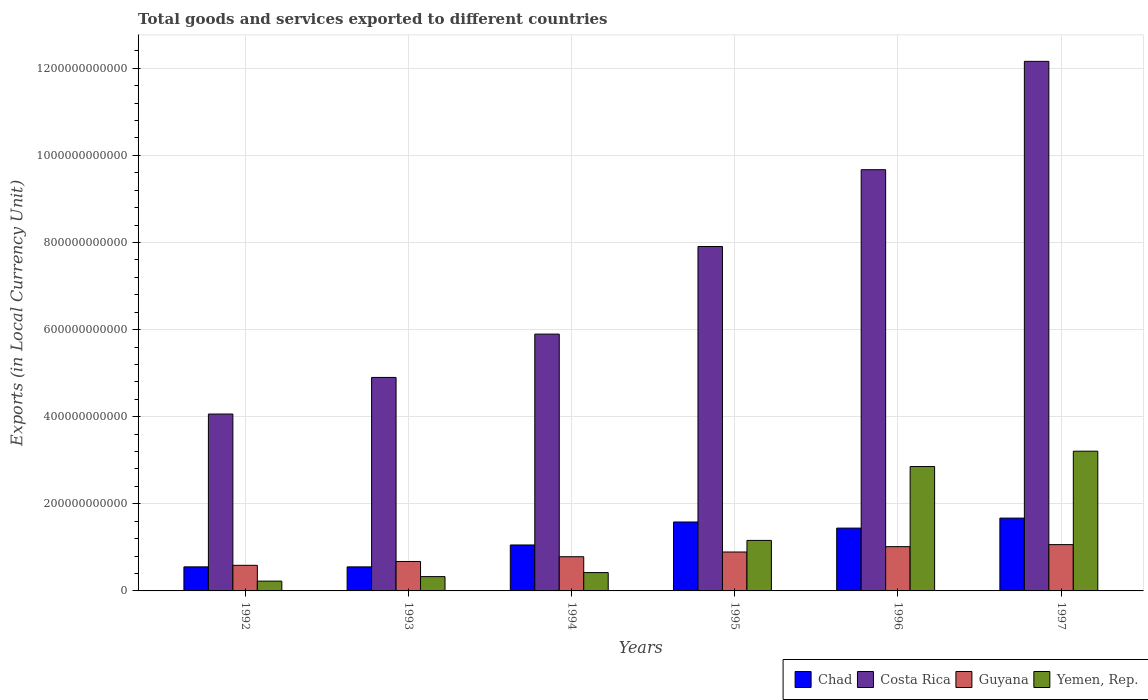How many different coloured bars are there?
Provide a short and direct response. 4. Are the number of bars on each tick of the X-axis equal?
Your answer should be compact. Yes. What is the label of the 3rd group of bars from the left?
Your answer should be compact. 1994. In how many cases, is the number of bars for a given year not equal to the number of legend labels?
Ensure brevity in your answer.  0. What is the Amount of goods and services exports in Yemen, Rep. in 1997?
Ensure brevity in your answer.  3.21e+11. Across all years, what is the maximum Amount of goods and services exports in Chad?
Make the answer very short. 1.67e+11. Across all years, what is the minimum Amount of goods and services exports in Costa Rica?
Your answer should be compact. 4.06e+11. What is the total Amount of goods and services exports in Chad in the graph?
Ensure brevity in your answer.  6.86e+11. What is the difference between the Amount of goods and services exports in Guyana in 1992 and that in 1994?
Provide a short and direct response. -1.97e+1. What is the difference between the Amount of goods and services exports in Guyana in 1992 and the Amount of goods and services exports in Chad in 1997?
Provide a short and direct response. -1.08e+11. What is the average Amount of goods and services exports in Yemen, Rep. per year?
Your response must be concise. 1.37e+11. In the year 1992, what is the difference between the Amount of goods and services exports in Yemen, Rep. and Amount of goods and services exports in Costa Rica?
Provide a succinct answer. -3.84e+11. In how many years, is the Amount of goods and services exports in Chad greater than 280000000000 LCU?
Your response must be concise. 0. What is the ratio of the Amount of goods and services exports in Chad in 1993 to that in 1997?
Your answer should be very brief. 0.33. Is the difference between the Amount of goods and services exports in Yemen, Rep. in 1992 and 1993 greater than the difference between the Amount of goods and services exports in Costa Rica in 1992 and 1993?
Offer a very short reply. Yes. What is the difference between the highest and the second highest Amount of goods and services exports in Chad?
Your answer should be compact. 8.92e+09. What is the difference between the highest and the lowest Amount of goods and services exports in Chad?
Offer a very short reply. 1.12e+11. In how many years, is the Amount of goods and services exports in Costa Rica greater than the average Amount of goods and services exports in Costa Rica taken over all years?
Provide a succinct answer. 3. What does the 2nd bar from the left in 1994 represents?
Your answer should be compact. Costa Rica. What does the 2nd bar from the right in 1992 represents?
Your response must be concise. Guyana. How many bars are there?
Offer a terse response. 24. Are all the bars in the graph horizontal?
Keep it short and to the point. No. What is the difference between two consecutive major ticks on the Y-axis?
Your answer should be very brief. 2.00e+11. Are the values on the major ticks of Y-axis written in scientific E-notation?
Provide a succinct answer. No. Does the graph contain any zero values?
Keep it short and to the point. No. Does the graph contain grids?
Ensure brevity in your answer.  Yes. How many legend labels are there?
Keep it short and to the point. 4. How are the legend labels stacked?
Offer a terse response. Horizontal. What is the title of the graph?
Offer a very short reply. Total goods and services exported to different countries. Does "Kazakhstan" appear as one of the legend labels in the graph?
Give a very brief answer. No. What is the label or title of the X-axis?
Make the answer very short. Years. What is the label or title of the Y-axis?
Your answer should be compact. Exports (in Local Currency Unit). What is the Exports (in Local Currency Unit) of Chad in 1992?
Your answer should be compact. 5.52e+1. What is the Exports (in Local Currency Unit) of Costa Rica in 1992?
Your response must be concise. 4.06e+11. What is the Exports (in Local Currency Unit) of Guyana in 1992?
Your response must be concise. 5.88e+1. What is the Exports (in Local Currency Unit) of Yemen, Rep. in 1992?
Your answer should be compact. 2.25e+1. What is the Exports (in Local Currency Unit) in Chad in 1993?
Make the answer very short. 5.52e+1. What is the Exports (in Local Currency Unit) of Costa Rica in 1993?
Your answer should be compact. 4.90e+11. What is the Exports (in Local Currency Unit) of Guyana in 1993?
Give a very brief answer. 6.76e+1. What is the Exports (in Local Currency Unit) of Yemen, Rep. in 1993?
Provide a short and direct response. 3.28e+1. What is the Exports (in Local Currency Unit) of Chad in 1994?
Make the answer very short. 1.06e+11. What is the Exports (in Local Currency Unit) of Costa Rica in 1994?
Make the answer very short. 5.90e+11. What is the Exports (in Local Currency Unit) in Guyana in 1994?
Your answer should be very brief. 7.85e+1. What is the Exports (in Local Currency Unit) of Yemen, Rep. in 1994?
Provide a succinct answer. 4.21e+1. What is the Exports (in Local Currency Unit) of Chad in 1995?
Provide a short and direct response. 1.58e+11. What is the Exports (in Local Currency Unit) in Costa Rica in 1995?
Your answer should be very brief. 7.91e+11. What is the Exports (in Local Currency Unit) in Guyana in 1995?
Keep it short and to the point. 8.93e+1. What is the Exports (in Local Currency Unit) of Yemen, Rep. in 1995?
Give a very brief answer. 1.16e+11. What is the Exports (in Local Currency Unit) in Chad in 1996?
Offer a terse response. 1.44e+11. What is the Exports (in Local Currency Unit) of Costa Rica in 1996?
Provide a short and direct response. 9.67e+11. What is the Exports (in Local Currency Unit) of Guyana in 1996?
Make the answer very short. 1.02e+11. What is the Exports (in Local Currency Unit) in Yemen, Rep. in 1996?
Make the answer very short. 2.86e+11. What is the Exports (in Local Currency Unit) of Chad in 1997?
Offer a very short reply. 1.67e+11. What is the Exports (in Local Currency Unit) of Costa Rica in 1997?
Give a very brief answer. 1.22e+12. What is the Exports (in Local Currency Unit) of Guyana in 1997?
Make the answer very short. 1.06e+11. What is the Exports (in Local Currency Unit) in Yemen, Rep. in 1997?
Provide a short and direct response. 3.21e+11. Across all years, what is the maximum Exports (in Local Currency Unit) in Chad?
Your response must be concise. 1.67e+11. Across all years, what is the maximum Exports (in Local Currency Unit) of Costa Rica?
Your answer should be very brief. 1.22e+12. Across all years, what is the maximum Exports (in Local Currency Unit) of Guyana?
Keep it short and to the point. 1.06e+11. Across all years, what is the maximum Exports (in Local Currency Unit) in Yemen, Rep.?
Your answer should be compact. 3.21e+11. Across all years, what is the minimum Exports (in Local Currency Unit) of Chad?
Provide a short and direct response. 5.52e+1. Across all years, what is the minimum Exports (in Local Currency Unit) in Costa Rica?
Provide a short and direct response. 4.06e+11. Across all years, what is the minimum Exports (in Local Currency Unit) of Guyana?
Ensure brevity in your answer.  5.88e+1. Across all years, what is the minimum Exports (in Local Currency Unit) of Yemen, Rep.?
Give a very brief answer. 2.25e+1. What is the total Exports (in Local Currency Unit) in Chad in the graph?
Give a very brief answer. 6.86e+11. What is the total Exports (in Local Currency Unit) of Costa Rica in the graph?
Provide a short and direct response. 4.46e+12. What is the total Exports (in Local Currency Unit) in Guyana in the graph?
Provide a short and direct response. 5.02e+11. What is the total Exports (in Local Currency Unit) of Yemen, Rep. in the graph?
Your answer should be very brief. 8.20e+11. What is the difference between the Exports (in Local Currency Unit) in Chad in 1992 and that in 1993?
Your answer should be very brief. 4.00e+07. What is the difference between the Exports (in Local Currency Unit) of Costa Rica in 1992 and that in 1993?
Provide a succinct answer. -8.41e+1. What is the difference between the Exports (in Local Currency Unit) in Guyana in 1992 and that in 1993?
Make the answer very short. -8.82e+09. What is the difference between the Exports (in Local Currency Unit) of Yemen, Rep. in 1992 and that in 1993?
Your answer should be compact. -1.03e+1. What is the difference between the Exports (in Local Currency Unit) in Chad in 1992 and that in 1994?
Ensure brevity in your answer.  -5.03e+1. What is the difference between the Exports (in Local Currency Unit) of Costa Rica in 1992 and that in 1994?
Ensure brevity in your answer.  -1.84e+11. What is the difference between the Exports (in Local Currency Unit) in Guyana in 1992 and that in 1994?
Give a very brief answer. -1.97e+1. What is the difference between the Exports (in Local Currency Unit) of Yemen, Rep. in 1992 and that in 1994?
Your answer should be compact. -1.96e+1. What is the difference between the Exports (in Local Currency Unit) of Chad in 1992 and that in 1995?
Your answer should be very brief. -1.03e+11. What is the difference between the Exports (in Local Currency Unit) in Costa Rica in 1992 and that in 1995?
Make the answer very short. -3.85e+11. What is the difference between the Exports (in Local Currency Unit) in Guyana in 1992 and that in 1995?
Make the answer very short. -3.06e+1. What is the difference between the Exports (in Local Currency Unit) in Yemen, Rep. in 1992 and that in 1995?
Your response must be concise. -9.34e+1. What is the difference between the Exports (in Local Currency Unit) in Chad in 1992 and that in 1996?
Ensure brevity in your answer.  -8.90e+1. What is the difference between the Exports (in Local Currency Unit) of Costa Rica in 1992 and that in 1996?
Your response must be concise. -5.61e+11. What is the difference between the Exports (in Local Currency Unit) in Guyana in 1992 and that in 1996?
Offer a very short reply. -4.29e+1. What is the difference between the Exports (in Local Currency Unit) of Yemen, Rep. in 1992 and that in 1996?
Provide a succinct answer. -2.63e+11. What is the difference between the Exports (in Local Currency Unit) of Chad in 1992 and that in 1997?
Your answer should be very brief. -1.12e+11. What is the difference between the Exports (in Local Currency Unit) of Costa Rica in 1992 and that in 1997?
Ensure brevity in your answer.  -8.10e+11. What is the difference between the Exports (in Local Currency Unit) of Guyana in 1992 and that in 1997?
Your answer should be compact. -4.75e+1. What is the difference between the Exports (in Local Currency Unit) in Yemen, Rep. in 1992 and that in 1997?
Offer a terse response. -2.98e+11. What is the difference between the Exports (in Local Currency Unit) in Chad in 1993 and that in 1994?
Your answer should be compact. -5.03e+1. What is the difference between the Exports (in Local Currency Unit) of Costa Rica in 1993 and that in 1994?
Offer a terse response. -9.95e+1. What is the difference between the Exports (in Local Currency Unit) in Guyana in 1993 and that in 1994?
Give a very brief answer. -1.09e+1. What is the difference between the Exports (in Local Currency Unit) in Yemen, Rep. in 1993 and that in 1994?
Give a very brief answer. -9.26e+09. What is the difference between the Exports (in Local Currency Unit) in Chad in 1993 and that in 1995?
Offer a terse response. -1.03e+11. What is the difference between the Exports (in Local Currency Unit) in Costa Rica in 1993 and that in 1995?
Offer a very short reply. -3.01e+11. What is the difference between the Exports (in Local Currency Unit) in Guyana in 1993 and that in 1995?
Your answer should be compact. -2.17e+1. What is the difference between the Exports (in Local Currency Unit) of Yemen, Rep. in 1993 and that in 1995?
Ensure brevity in your answer.  -8.31e+1. What is the difference between the Exports (in Local Currency Unit) in Chad in 1993 and that in 1996?
Offer a very short reply. -8.90e+1. What is the difference between the Exports (in Local Currency Unit) in Costa Rica in 1993 and that in 1996?
Your response must be concise. -4.77e+11. What is the difference between the Exports (in Local Currency Unit) in Guyana in 1993 and that in 1996?
Your response must be concise. -3.40e+1. What is the difference between the Exports (in Local Currency Unit) in Yemen, Rep. in 1993 and that in 1996?
Give a very brief answer. -2.53e+11. What is the difference between the Exports (in Local Currency Unit) of Chad in 1993 and that in 1997?
Offer a very short reply. -1.12e+11. What is the difference between the Exports (in Local Currency Unit) in Costa Rica in 1993 and that in 1997?
Ensure brevity in your answer.  -7.26e+11. What is the difference between the Exports (in Local Currency Unit) of Guyana in 1993 and that in 1997?
Ensure brevity in your answer.  -3.87e+1. What is the difference between the Exports (in Local Currency Unit) in Yemen, Rep. in 1993 and that in 1997?
Your answer should be compact. -2.88e+11. What is the difference between the Exports (in Local Currency Unit) of Chad in 1994 and that in 1995?
Keep it short and to the point. -5.28e+1. What is the difference between the Exports (in Local Currency Unit) in Costa Rica in 1994 and that in 1995?
Your answer should be very brief. -2.01e+11. What is the difference between the Exports (in Local Currency Unit) of Guyana in 1994 and that in 1995?
Offer a terse response. -1.08e+1. What is the difference between the Exports (in Local Currency Unit) in Yemen, Rep. in 1994 and that in 1995?
Provide a short and direct response. -7.39e+1. What is the difference between the Exports (in Local Currency Unit) of Chad in 1994 and that in 1996?
Your answer should be compact. -3.88e+1. What is the difference between the Exports (in Local Currency Unit) of Costa Rica in 1994 and that in 1996?
Offer a very short reply. -3.77e+11. What is the difference between the Exports (in Local Currency Unit) in Guyana in 1994 and that in 1996?
Provide a short and direct response. -2.31e+1. What is the difference between the Exports (in Local Currency Unit) in Yemen, Rep. in 1994 and that in 1996?
Make the answer very short. -2.43e+11. What is the difference between the Exports (in Local Currency Unit) in Chad in 1994 and that in 1997?
Give a very brief answer. -6.17e+1. What is the difference between the Exports (in Local Currency Unit) in Costa Rica in 1994 and that in 1997?
Offer a very short reply. -6.26e+11. What is the difference between the Exports (in Local Currency Unit) of Guyana in 1994 and that in 1997?
Make the answer very short. -2.78e+1. What is the difference between the Exports (in Local Currency Unit) of Yemen, Rep. in 1994 and that in 1997?
Provide a short and direct response. -2.79e+11. What is the difference between the Exports (in Local Currency Unit) in Chad in 1995 and that in 1996?
Your answer should be very brief. 1.40e+1. What is the difference between the Exports (in Local Currency Unit) in Costa Rica in 1995 and that in 1996?
Your response must be concise. -1.76e+11. What is the difference between the Exports (in Local Currency Unit) of Guyana in 1995 and that in 1996?
Provide a short and direct response. -1.23e+1. What is the difference between the Exports (in Local Currency Unit) of Yemen, Rep. in 1995 and that in 1996?
Ensure brevity in your answer.  -1.70e+11. What is the difference between the Exports (in Local Currency Unit) in Chad in 1995 and that in 1997?
Ensure brevity in your answer.  -8.92e+09. What is the difference between the Exports (in Local Currency Unit) in Costa Rica in 1995 and that in 1997?
Provide a succinct answer. -4.25e+11. What is the difference between the Exports (in Local Currency Unit) of Guyana in 1995 and that in 1997?
Give a very brief answer. -1.70e+1. What is the difference between the Exports (in Local Currency Unit) of Yemen, Rep. in 1995 and that in 1997?
Offer a very short reply. -2.05e+11. What is the difference between the Exports (in Local Currency Unit) in Chad in 1996 and that in 1997?
Offer a terse response. -2.29e+1. What is the difference between the Exports (in Local Currency Unit) in Costa Rica in 1996 and that in 1997?
Your answer should be very brief. -2.49e+11. What is the difference between the Exports (in Local Currency Unit) in Guyana in 1996 and that in 1997?
Your answer should be very brief. -4.68e+09. What is the difference between the Exports (in Local Currency Unit) of Yemen, Rep. in 1996 and that in 1997?
Offer a terse response. -3.52e+1. What is the difference between the Exports (in Local Currency Unit) of Chad in 1992 and the Exports (in Local Currency Unit) of Costa Rica in 1993?
Give a very brief answer. -4.35e+11. What is the difference between the Exports (in Local Currency Unit) of Chad in 1992 and the Exports (in Local Currency Unit) of Guyana in 1993?
Your answer should be very brief. -1.23e+1. What is the difference between the Exports (in Local Currency Unit) in Chad in 1992 and the Exports (in Local Currency Unit) in Yemen, Rep. in 1993?
Your answer should be very brief. 2.24e+1. What is the difference between the Exports (in Local Currency Unit) in Costa Rica in 1992 and the Exports (in Local Currency Unit) in Guyana in 1993?
Keep it short and to the point. 3.39e+11. What is the difference between the Exports (in Local Currency Unit) in Costa Rica in 1992 and the Exports (in Local Currency Unit) in Yemen, Rep. in 1993?
Your response must be concise. 3.73e+11. What is the difference between the Exports (in Local Currency Unit) of Guyana in 1992 and the Exports (in Local Currency Unit) of Yemen, Rep. in 1993?
Provide a short and direct response. 2.59e+1. What is the difference between the Exports (in Local Currency Unit) of Chad in 1992 and the Exports (in Local Currency Unit) of Costa Rica in 1994?
Keep it short and to the point. -5.34e+11. What is the difference between the Exports (in Local Currency Unit) of Chad in 1992 and the Exports (in Local Currency Unit) of Guyana in 1994?
Provide a short and direct response. -2.33e+1. What is the difference between the Exports (in Local Currency Unit) in Chad in 1992 and the Exports (in Local Currency Unit) in Yemen, Rep. in 1994?
Make the answer very short. 1.32e+1. What is the difference between the Exports (in Local Currency Unit) in Costa Rica in 1992 and the Exports (in Local Currency Unit) in Guyana in 1994?
Offer a very short reply. 3.28e+11. What is the difference between the Exports (in Local Currency Unit) of Costa Rica in 1992 and the Exports (in Local Currency Unit) of Yemen, Rep. in 1994?
Offer a very short reply. 3.64e+11. What is the difference between the Exports (in Local Currency Unit) of Guyana in 1992 and the Exports (in Local Currency Unit) of Yemen, Rep. in 1994?
Your answer should be very brief. 1.67e+1. What is the difference between the Exports (in Local Currency Unit) of Chad in 1992 and the Exports (in Local Currency Unit) of Costa Rica in 1995?
Provide a short and direct response. -7.36e+11. What is the difference between the Exports (in Local Currency Unit) of Chad in 1992 and the Exports (in Local Currency Unit) of Guyana in 1995?
Your response must be concise. -3.41e+1. What is the difference between the Exports (in Local Currency Unit) of Chad in 1992 and the Exports (in Local Currency Unit) of Yemen, Rep. in 1995?
Your answer should be compact. -6.07e+1. What is the difference between the Exports (in Local Currency Unit) of Costa Rica in 1992 and the Exports (in Local Currency Unit) of Guyana in 1995?
Offer a very short reply. 3.17e+11. What is the difference between the Exports (in Local Currency Unit) in Costa Rica in 1992 and the Exports (in Local Currency Unit) in Yemen, Rep. in 1995?
Provide a succinct answer. 2.90e+11. What is the difference between the Exports (in Local Currency Unit) of Guyana in 1992 and the Exports (in Local Currency Unit) of Yemen, Rep. in 1995?
Your answer should be very brief. -5.72e+1. What is the difference between the Exports (in Local Currency Unit) of Chad in 1992 and the Exports (in Local Currency Unit) of Costa Rica in 1996?
Your response must be concise. -9.12e+11. What is the difference between the Exports (in Local Currency Unit) of Chad in 1992 and the Exports (in Local Currency Unit) of Guyana in 1996?
Give a very brief answer. -4.64e+1. What is the difference between the Exports (in Local Currency Unit) in Chad in 1992 and the Exports (in Local Currency Unit) in Yemen, Rep. in 1996?
Your answer should be very brief. -2.30e+11. What is the difference between the Exports (in Local Currency Unit) of Costa Rica in 1992 and the Exports (in Local Currency Unit) of Guyana in 1996?
Your answer should be compact. 3.04e+11. What is the difference between the Exports (in Local Currency Unit) of Costa Rica in 1992 and the Exports (in Local Currency Unit) of Yemen, Rep. in 1996?
Offer a very short reply. 1.21e+11. What is the difference between the Exports (in Local Currency Unit) in Guyana in 1992 and the Exports (in Local Currency Unit) in Yemen, Rep. in 1996?
Give a very brief answer. -2.27e+11. What is the difference between the Exports (in Local Currency Unit) of Chad in 1992 and the Exports (in Local Currency Unit) of Costa Rica in 1997?
Your answer should be very brief. -1.16e+12. What is the difference between the Exports (in Local Currency Unit) in Chad in 1992 and the Exports (in Local Currency Unit) in Guyana in 1997?
Your answer should be very brief. -5.11e+1. What is the difference between the Exports (in Local Currency Unit) of Chad in 1992 and the Exports (in Local Currency Unit) of Yemen, Rep. in 1997?
Offer a terse response. -2.66e+11. What is the difference between the Exports (in Local Currency Unit) in Costa Rica in 1992 and the Exports (in Local Currency Unit) in Guyana in 1997?
Keep it short and to the point. 3.00e+11. What is the difference between the Exports (in Local Currency Unit) of Costa Rica in 1992 and the Exports (in Local Currency Unit) of Yemen, Rep. in 1997?
Ensure brevity in your answer.  8.53e+1. What is the difference between the Exports (in Local Currency Unit) in Guyana in 1992 and the Exports (in Local Currency Unit) in Yemen, Rep. in 1997?
Offer a very short reply. -2.62e+11. What is the difference between the Exports (in Local Currency Unit) in Chad in 1993 and the Exports (in Local Currency Unit) in Costa Rica in 1994?
Your answer should be compact. -5.34e+11. What is the difference between the Exports (in Local Currency Unit) of Chad in 1993 and the Exports (in Local Currency Unit) of Guyana in 1994?
Give a very brief answer. -2.33e+1. What is the difference between the Exports (in Local Currency Unit) in Chad in 1993 and the Exports (in Local Currency Unit) in Yemen, Rep. in 1994?
Offer a terse response. 1.31e+1. What is the difference between the Exports (in Local Currency Unit) of Costa Rica in 1993 and the Exports (in Local Currency Unit) of Guyana in 1994?
Provide a short and direct response. 4.12e+11. What is the difference between the Exports (in Local Currency Unit) of Costa Rica in 1993 and the Exports (in Local Currency Unit) of Yemen, Rep. in 1994?
Your answer should be compact. 4.48e+11. What is the difference between the Exports (in Local Currency Unit) of Guyana in 1993 and the Exports (in Local Currency Unit) of Yemen, Rep. in 1994?
Keep it short and to the point. 2.55e+1. What is the difference between the Exports (in Local Currency Unit) of Chad in 1993 and the Exports (in Local Currency Unit) of Costa Rica in 1995?
Your answer should be very brief. -7.36e+11. What is the difference between the Exports (in Local Currency Unit) of Chad in 1993 and the Exports (in Local Currency Unit) of Guyana in 1995?
Your answer should be very brief. -3.41e+1. What is the difference between the Exports (in Local Currency Unit) of Chad in 1993 and the Exports (in Local Currency Unit) of Yemen, Rep. in 1995?
Offer a very short reply. -6.08e+1. What is the difference between the Exports (in Local Currency Unit) of Costa Rica in 1993 and the Exports (in Local Currency Unit) of Guyana in 1995?
Ensure brevity in your answer.  4.01e+11. What is the difference between the Exports (in Local Currency Unit) in Costa Rica in 1993 and the Exports (in Local Currency Unit) in Yemen, Rep. in 1995?
Make the answer very short. 3.74e+11. What is the difference between the Exports (in Local Currency Unit) of Guyana in 1993 and the Exports (in Local Currency Unit) of Yemen, Rep. in 1995?
Provide a succinct answer. -4.84e+1. What is the difference between the Exports (in Local Currency Unit) in Chad in 1993 and the Exports (in Local Currency Unit) in Costa Rica in 1996?
Give a very brief answer. -9.12e+11. What is the difference between the Exports (in Local Currency Unit) of Chad in 1993 and the Exports (in Local Currency Unit) of Guyana in 1996?
Offer a very short reply. -4.64e+1. What is the difference between the Exports (in Local Currency Unit) in Chad in 1993 and the Exports (in Local Currency Unit) in Yemen, Rep. in 1996?
Make the answer very short. -2.30e+11. What is the difference between the Exports (in Local Currency Unit) of Costa Rica in 1993 and the Exports (in Local Currency Unit) of Guyana in 1996?
Keep it short and to the point. 3.89e+11. What is the difference between the Exports (in Local Currency Unit) in Costa Rica in 1993 and the Exports (in Local Currency Unit) in Yemen, Rep. in 1996?
Offer a terse response. 2.05e+11. What is the difference between the Exports (in Local Currency Unit) of Guyana in 1993 and the Exports (in Local Currency Unit) of Yemen, Rep. in 1996?
Offer a very short reply. -2.18e+11. What is the difference between the Exports (in Local Currency Unit) in Chad in 1993 and the Exports (in Local Currency Unit) in Costa Rica in 1997?
Your answer should be compact. -1.16e+12. What is the difference between the Exports (in Local Currency Unit) in Chad in 1993 and the Exports (in Local Currency Unit) in Guyana in 1997?
Ensure brevity in your answer.  -5.11e+1. What is the difference between the Exports (in Local Currency Unit) in Chad in 1993 and the Exports (in Local Currency Unit) in Yemen, Rep. in 1997?
Keep it short and to the point. -2.66e+11. What is the difference between the Exports (in Local Currency Unit) of Costa Rica in 1993 and the Exports (in Local Currency Unit) of Guyana in 1997?
Your response must be concise. 3.84e+11. What is the difference between the Exports (in Local Currency Unit) in Costa Rica in 1993 and the Exports (in Local Currency Unit) in Yemen, Rep. in 1997?
Give a very brief answer. 1.69e+11. What is the difference between the Exports (in Local Currency Unit) in Guyana in 1993 and the Exports (in Local Currency Unit) in Yemen, Rep. in 1997?
Keep it short and to the point. -2.53e+11. What is the difference between the Exports (in Local Currency Unit) of Chad in 1994 and the Exports (in Local Currency Unit) of Costa Rica in 1995?
Your answer should be compact. -6.85e+11. What is the difference between the Exports (in Local Currency Unit) of Chad in 1994 and the Exports (in Local Currency Unit) of Guyana in 1995?
Ensure brevity in your answer.  1.62e+1. What is the difference between the Exports (in Local Currency Unit) of Chad in 1994 and the Exports (in Local Currency Unit) of Yemen, Rep. in 1995?
Offer a very short reply. -1.05e+1. What is the difference between the Exports (in Local Currency Unit) in Costa Rica in 1994 and the Exports (in Local Currency Unit) in Guyana in 1995?
Offer a very short reply. 5.00e+11. What is the difference between the Exports (in Local Currency Unit) in Costa Rica in 1994 and the Exports (in Local Currency Unit) in Yemen, Rep. in 1995?
Make the answer very short. 4.74e+11. What is the difference between the Exports (in Local Currency Unit) of Guyana in 1994 and the Exports (in Local Currency Unit) of Yemen, Rep. in 1995?
Provide a succinct answer. -3.74e+1. What is the difference between the Exports (in Local Currency Unit) of Chad in 1994 and the Exports (in Local Currency Unit) of Costa Rica in 1996?
Your answer should be compact. -8.62e+11. What is the difference between the Exports (in Local Currency Unit) of Chad in 1994 and the Exports (in Local Currency Unit) of Guyana in 1996?
Offer a terse response. 3.86e+09. What is the difference between the Exports (in Local Currency Unit) of Chad in 1994 and the Exports (in Local Currency Unit) of Yemen, Rep. in 1996?
Provide a succinct answer. -1.80e+11. What is the difference between the Exports (in Local Currency Unit) in Costa Rica in 1994 and the Exports (in Local Currency Unit) in Guyana in 1996?
Make the answer very short. 4.88e+11. What is the difference between the Exports (in Local Currency Unit) of Costa Rica in 1994 and the Exports (in Local Currency Unit) of Yemen, Rep. in 1996?
Your answer should be compact. 3.04e+11. What is the difference between the Exports (in Local Currency Unit) in Guyana in 1994 and the Exports (in Local Currency Unit) in Yemen, Rep. in 1996?
Provide a succinct answer. -2.07e+11. What is the difference between the Exports (in Local Currency Unit) in Chad in 1994 and the Exports (in Local Currency Unit) in Costa Rica in 1997?
Your answer should be compact. -1.11e+12. What is the difference between the Exports (in Local Currency Unit) of Chad in 1994 and the Exports (in Local Currency Unit) of Guyana in 1997?
Your answer should be very brief. -8.15e+08. What is the difference between the Exports (in Local Currency Unit) of Chad in 1994 and the Exports (in Local Currency Unit) of Yemen, Rep. in 1997?
Your response must be concise. -2.15e+11. What is the difference between the Exports (in Local Currency Unit) of Costa Rica in 1994 and the Exports (in Local Currency Unit) of Guyana in 1997?
Your answer should be very brief. 4.83e+11. What is the difference between the Exports (in Local Currency Unit) of Costa Rica in 1994 and the Exports (in Local Currency Unit) of Yemen, Rep. in 1997?
Ensure brevity in your answer.  2.69e+11. What is the difference between the Exports (in Local Currency Unit) in Guyana in 1994 and the Exports (in Local Currency Unit) in Yemen, Rep. in 1997?
Your answer should be compact. -2.42e+11. What is the difference between the Exports (in Local Currency Unit) in Chad in 1995 and the Exports (in Local Currency Unit) in Costa Rica in 1996?
Provide a succinct answer. -8.09e+11. What is the difference between the Exports (in Local Currency Unit) of Chad in 1995 and the Exports (in Local Currency Unit) of Guyana in 1996?
Provide a short and direct response. 5.66e+1. What is the difference between the Exports (in Local Currency Unit) in Chad in 1995 and the Exports (in Local Currency Unit) in Yemen, Rep. in 1996?
Your answer should be compact. -1.27e+11. What is the difference between the Exports (in Local Currency Unit) in Costa Rica in 1995 and the Exports (in Local Currency Unit) in Guyana in 1996?
Your response must be concise. 6.89e+11. What is the difference between the Exports (in Local Currency Unit) of Costa Rica in 1995 and the Exports (in Local Currency Unit) of Yemen, Rep. in 1996?
Ensure brevity in your answer.  5.05e+11. What is the difference between the Exports (in Local Currency Unit) of Guyana in 1995 and the Exports (in Local Currency Unit) of Yemen, Rep. in 1996?
Your answer should be very brief. -1.96e+11. What is the difference between the Exports (in Local Currency Unit) in Chad in 1995 and the Exports (in Local Currency Unit) in Costa Rica in 1997?
Your response must be concise. -1.06e+12. What is the difference between the Exports (in Local Currency Unit) of Chad in 1995 and the Exports (in Local Currency Unit) of Guyana in 1997?
Offer a terse response. 5.20e+1. What is the difference between the Exports (in Local Currency Unit) of Chad in 1995 and the Exports (in Local Currency Unit) of Yemen, Rep. in 1997?
Your answer should be very brief. -1.63e+11. What is the difference between the Exports (in Local Currency Unit) in Costa Rica in 1995 and the Exports (in Local Currency Unit) in Guyana in 1997?
Your answer should be very brief. 6.84e+11. What is the difference between the Exports (in Local Currency Unit) in Costa Rica in 1995 and the Exports (in Local Currency Unit) in Yemen, Rep. in 1997?
Your response must be concise. 4.70e+11. What is the difference between the Exports (in Local Currency Unit) of Guyana in 1995 and the Exports (in Local Currency Unit) of Yemen, Rep. in 1997?
Your answer should be very brief. -2.31e+11. What is the difference between the Exports (in Local Currency Unit) in Chad in 1996 and the Exports (in Local Currency Unit) in Costa Rica in 1997?
Ensure brevity in your answer.  -1.07e+12. What is the difference between the Exports (in Local Currency Unit) of Chad in 1996 and the Exports (in Local Currency Unit) of Guyana in 1997?
Your response must be concise. 3.79e+1. What is the difference between the Exports (in Local Currency Unit) in Chad in 1996 and the Exports (in Local Currency Unit) in Yemen, Rep. in 1997?
Offer a very short reply. -1.77e+11. What is the difference between the Exports (in Local Currency Unit) of Costa Rica in 1996 and the Exports (in Local Currency Unit) of Guyana in 1997?
Ensure brevity in your answer.  8.61e+11. What is the difference between the Exports (in Local Currency Unit) of Costa Rica in 1996 and the Exports (in Local Currency Unit) of Yemen, Rep. in 1997?
Your answer should be very brief. 6.46e+11. What is the difference between the Exports (in Local Currency Unit) of Guyana in 1996 and the Exports (in Local Currency Unit) of Yemen, Rep. in 1997?
Your response must be concise. -2.19e+11. What is the average Exports (in Local Currency Unit) in Chad per year?
Your response must be concise. 1.14e+11. What is the average Exports (in Local Currency Unit) in Costa Rica per year?
Offer a terse response. 7.43e+11. What is the average Exports (in Local Currency Unit) of Guyana per year?
Offer a very short reply. 8.37e+1. What is the average Exports (in Local Currency Unit) of Yemen, Rep. per year?
Provide a succinct answer. 1.37e+11. In the year 1992, what is the difference between the Exports (in Local Currency Unit) of Chad and Exports (in Local Currency Unit) of Costa Rica?
Offer a very short reply. -3.51e+11. In the year 1992, what is the difference between the Exports (in Local Currency Unit) in Chad and Exports (in Local Currency Unit) in Guyana?
Your answer should be very brief. -3.52e+09. In the year 1992, what is the difference between the Exports (in Local Currency Unit) in Chad and Exports (in Local Currency Unit) in Yemen, Rep.?
Offer a terse response. 3.27e+1. In the year 1992, what is the difference between the Exports (in Local Currency Unit) in Costa Rica and Exports (in Local Currency Unit) in Guyana?
Ensure brevity in your answer.  3.47e+11. In the year 1992, what is the difference between the Exports (in Local Currency Unit) of Costa Rica and Exports (in Local Currency Unit) of Yemen, Rep.?
Give a very brief answer. 3.84e+11. In the year 1992, what is the difference between the Exports (in Local Currency Unit) in Guyana and Exports (in Local Currency Unit) in Yemen, Rep.?
Your response must be concise. 3.63e+1. In the year 1993, what is the difference between the Exports (in Local Currency Unit) of Chad and Exports (in Local Currency Unit) of Costa Rica?
Ensure brevity in your answer.  -4.35e+11. In the year 1993, what is the difference between the Exports (in Local Currency Unit) of Chad and Exports (in Local Currency Unit) of Guyana?
Make the answer very short. -1.24e+1. In the year 1993, what is the difference between the Exports (in Local Currency Unit) in Chad and Exports (in Local Currency Unit) in Yemen, Rep.?
Your response must be concise. 2.24e+1. In the year 1993, what is the difference between the Exports (in Local Currency Unit) of Costa Rica and Exports (in Local Currency Unit) of Guyana?
Keep it short and to the point. 4.23e+11. In the year 1993, what is the difference between the Exports (in Local Currency Unit) of Costa Rica and Exports (in Local Currency Unit) of Yemen, Rep.?
Provide a succinct answer. 4.57e+11. In the year 1993, what is the difference between the Exports (in Local Currency Unit) of Guyana and Exports (in Local Currency Unit) of Yemen, Rep.?
Ensure brevity in your answer.  3.48e+1. In the year 1994, what is the difference between the Exports (in Local Currency Unit) of Chad and Exports (in Local Currency Unit) of Costa Rica?
Ensure brevity in your answer.  -4.84e+11. In the year 1994, what is the difference between the Exports (in Local Currency Unit) of Chad and Exports (in Local Currency Unit) of Guyana?
Ensure brevity in your answer.  2.70e+1. In the year 1994, what is the difference between the Exports (in Local Currency Unit) of Chad and Exports (in Local Currency Unit) of Yemen, Rep.?
Your answer should be very brief. 6.34e+1. In the year 1994, what is the difference between the Exports (in Local Currency Unit) in Costa Rica and Exports (in Local Currency Unit) in Guyana?
Provide a succinct answer. 5.11e+11. In the year 1994, what is the difference between the Exports (in Local Currency Unit) of Costa Rica and Exports (in Local Currency Unit) of Yemen, Rep.?
Keep it short and to the point. 5.48e+11. In the year 1994, what is the difference between the Exports (in Local Currency Unit) of Guyana and Exports (in Local Currency Unit) of Yemen, Rep.?
Your response must be concise. 3.64e+1. In the year 1995, what is the difference between the Exports (in Local Currency Unit) of Chad and Exports (in Local Currency Unit) of Costa Rica?
Make the answer very short. -6.33e+11. In the year 1995, what is the difference between the Exports (in Local Currency Unit) of Chad and Exports (in Local Currency Unit) of Guyana?
Offer a very short reply. 6.89e+1. In the year 1995, what is the difference between the Exports (in Local Currency Unit) of Chad and Exports (in Local Currency Unit) of Yemen, Rep.?
Offer a very short reply. 4.23e+1. In the year 1995, what is the difference between the Exports (in Local Currency Unit) in Costa Rica and Exports (in Local Currency Unit) in Guyana?
Keep it short and to the point. 7.01e+11. In the year 1995, what is the difference between the Exports (in Local Currency Unit) of Costa Rica and Exports (in Local Currency Unit) of Yemen, Rep.?
Provide a succinct answer. 6.75e+11. In the year 1995, what is the difference between the Exports (in Local Currency Unit) of Guyana and Exports (in Local Currency Unit) of Yemen, Rep.?
Keep it short and to the point. -2.66e+1. In the year 1996, what is the difference between the Exports (in Local Currency Unit) in Chad and Exports (in Local Currency Unit) in Costa Rica?
Give a very brief answer. -8.23e+11. In the year 1996, what is the difference between the Exports (in Local Currency Unit) of Chad and Exports (in Local Currency Unit) of Guyana?
Offer a terse response. 4.26e+1. In the year 1996, what is the difference between the Exports (in Local Currency Unit) of Chad and Exports (in Local Currency Unit) of Yemen, Rep.?
Give a very brief answer. -1.41e+11. In the year 1996, what is the difference between the Exports (in Local Currency Unit) in Costa Rica and Exports (in Local Currency Unit) in Guyana?
Your answer should be very brief. 8.65e+11. In the year 1996, what is the difference between the Exports (in Local Currency Unit) in Costa Rica and Exports (in Local Currency Unit) in Yemen, Rep.?
Make the answer very short. 6.82e+11. In the year 1996, what is the difference between the Exports (in Local Currency Unit) of Guyana and Exports (in Local Currency Unit) of Yemen, Rep.?
Provide a succinct answer. -1.84e+11. In the year 1997, what is the difference between the Exports (in Local Currency Unit) of Chad and Exports (in Local Currency Unit) of Costa Rica?
Ensure brevity in your answer.  -1.05e+12. In the year 1997, what is the difference between the Exports (in Local Currency Unit) in Chad and Exports (in Local Currency Unit) in Guyana?
Your response must be concise. 6.09e+1. In the year 1997, what is the difference between the Exports (in Local Currency Unit) in Chad and Exports (in Local Currency Unit) in Yemen, Rep.?
Ensure brevity in your answer.  -1.54e+11. In the year 1997, what is the difference between the Exports (in Local Currency Unit) in Costa Rica and Exports (in Local Currency Unit) in Guyana?
Your answer should be compact. 1.11e+12. In the year 1997, what is the difference between the Exports (in Local Currency Unit) of Costa Rica and Exports (in Local Currency Unit) of Yemen, Rep.?
Make the answer very short. 8.95e+11. In the year 1997, what is the difference between the Exports (in Local Currency Unit) of Guyana and Exports (in Local Currency Unit) of Yemen, Rep.?
Provide a short and direct response. -2.15e+11. What is the ratio of the Exports (in Local Currency Unit) in Chad in 1992 to that in 1993?
Provide a short and direct response. 1. What is the ratio of the Exports (in Local Currency Unit) in Costa Rica in 1992 to that in 1993?
Your answer should be very brief. 0.83. What is the ratio of the Exports (in Local Currency Unit) in Guyana in 1992 to that in 1993?
Give a very brief answer. 0.87. What is the ratio of the Exports (in Local Currency Unit) of Yemen, Rep. in 1992 to that in 1993?
Provide a succinct answer. 0.69. What is the ratio of the Exports (in Local Currency Unit) in Chad in 1992 to that in 1994?
Your response must be concise. 0.52. What is the ratio of the Exports (in Local Currency Unit) in Costa Rica in 1992 to that in 1994?
Offer a terse response. 0.69. What is the ratio of the Exports (in Local Currency Unit) of Guyana in 1992 to that in 1994?
Your answer should be very brief. 0.75. What is the ratio of the Exports (in Local Currency Unit) of Yemen, Rep. in 1992 to that in 1994?
Your answer should be very brief. 0.53. What is the ratio of the Exports (in Local Currency Unit) of Chad in 1992 to that in 1995?
Your answer should be very brief. 0.35. What is the ratio of the Exports (in Local Currency Unit) of Costa Rica in 1992 to that in 1995?
Your response must be concise. 0.51. What is the ratio of the Exports (in Local Currency Unit) of Guyana in 1992 to that in 1995?
Offer a very short reply. 0.66. What is the ratio of the Exports (in Local Currency Unit) of Yemen, Rep. in 1992 to that in 1995?
Offer a very short reply. 0.19. What is the ratio of the Exports (in Local Currency Unit) in Chad in 1992 to that in 1996?
Provide a short and direct response. 0.38. What is the ratio of the Exports (in Local Currency Unit) in Costa Rica in 1992 to that in 1996?
Provide a succinct answer. 0.42. What is the ratio of the Exports (in Local Currency Unit) of Guyana in 1992 to that in 1996?
Keep it short and to the point. 0.58. What is the ratio of the Exports (in Local Currency Unit) in Yemen, Rep. in 1992 to that in 1996?
Provide a succinct answer. 0.08. What is the ratio of the Exports (in Local Currency Unit) of Chad in 1992 to that in 1997?
Your response must be concise. 0.33. What is the ratio of the Exports (in Local Currency Unit) in Costa Rica in 1992 to that in 1997?
Keep it short and to the point. 0.33. What is the ratio of the Exports (in Local Currency Unit) of Guyana in 1992 to that in 1997?
Keep it short and to the point. 0.55. What is the ratio of the Exports (in Local Currency Unit) in Yemen, Rep. in 1992 to that in 1997?
Give a very brief answer. 0.07. What is the ratio of the Exports (in Local Currency Unit) of Chad in 1993 to that in 1994?
Your response must be concise. 0.52. What is the ratio of the Exports (in Local Currency Unit) in Costa Rica in 1993 to that in 1994?
Keep it short and to the point. 0.83. What is the ratio of the Exports (in Local Currency Unit) in Guyana in 1993 to that in 1994?
Give a very brief answer. 0.86. What is the ratio of the Exports (in Local Currency Unit) in Yemen, Rep. in 1993 to that in 1994?
Offer a terse response. 0.78. What is the ratio of the Exports (in Local Currency Unit) of Chad in 1993 to that in 1995?
Give a very brief answer. 0.35. What is the ratio of the Exports (in Local Currency Unit) in Costa Rica in 1993 to that in 1995?
Give a very brief answer. 0.62. What is the ratio of the Exports (in Local Currency Unit) of Guyana in 1993 to that in 1995?
Your answer should be compact. 0.76. What is the ratio of the Exports (in Local Currency Unit) of Yemen, Rep. in 1993 to that in 1995?
Your answer should be compact. 0.28. What is the ratio of the Exports (in Local Currency Unit) of Chad in 1993 to that in 1996?
Your response must be concise. 0.38. What is the ratio of the Exports (in Local Currency Unit) of Costa Rica in 1993 to that in 1996?
Offer a very short reply. 0.51. What is the ratio of the Exports (in Local Currency Unit) of Guyana in 1993 to that in 1996?
Provide a short and direct response. 0.67. What is the ratio of the Exports (in Local Currency Unit) in Yemen, Rep. in 1993 to that in 1996?
Keep it short and to the point. 0.12. What is the ratio of the Exports (in Local Currency Unit) of Chad in 1993 to that in 1997?
Offer a very short reply. 0.33. What is the ratio of the Exports (in Local Currency Unit) of Costa Rica in 1993 to that in 1997?
Offer a terse response. 0.4. What is the ratio of the Exports (in Local Currency Unit) of Guyana in 1993 to that in 1997?
Your answer should be very brief. 0.64. What is the ratio of the Exports (in Local Currency Unit) in Yemen, Rep. in 1993 to that in 1997?
Your answer should be compact. 0.1. What is the ratio of the Exports (in Local Currency Unit) of Chad in 1994 to that in 1995?
Ensure brevity in your answer.  0.67. What is the ratio of the Exports (in Local Currency Unit) in Costa Rica in 1994 to that in 1995?
Provide a succinct answer. 0.75. What is the ratio of the Exports (in Local Currency Unit) of Guyana in 1994 to that in 1995?
Your answer should be very brief. 0.88. What is the ratio of the Exports (in Local Currency Unit) of Yemen, Rep. in 1994 to that in 1995?
Offer a terse response. 0.36. What is the ratio of the Exports (in Local Currency Unit) in Chad in 1994 to that in 1996?
Ensure brevity in your answer.  0.73. What is the ratio of the Exports (in Local Currency Unit) of Costa Rica in 1994 to that in 1996?
Your answer should be compact. 0.61. What is the ratio of the Exports (in Local Currency Unit) of Guyana in 1994 to that in 1996?
Make the answer very short. 0.77. What is the ratio of the Exports (in Local Currency Unit) of Yemen, Rep. in 1994 to that in 1996?
Give a very brief answer. 0.15. What is the ratio of the Exports (in Local Currency Unit) of Chad in 1994 to that in 1997?
Your answer should be very brief. 0.63. What is the ratio of the Exports (in Local Currency Unit) of Costa Rica in 1994 to that in 1997?
Provide a short and direct response. 0.48. What is the ratio of the Exports (in Local Currency Unit) of Guyana in 1994 to that in 1997?
Give a very brief answer. 0.74. What is the ratio of the Exports (in Local Currency Unit) of Yemen, Rep. in 1994 to that in 1997?
Keep it short and to the point. 0.13. What is the ratio of the Exports (in Local Currency Unit) in Chad in 1995 to that in 1996?
Ensure brevity in your answer.  1.1. What is the ratio of the Exports (in Local Currency Unit) of Costa Rica in 1995 to that in 1996?
Your answer should be compact. 0.82. What is the ratio of the Exports (in Local Currency Unit) in Guyana in 1995 to that in 1996?
Offer a terse response. 0.88. What is the ratio of the Exports (in Local Currency Unit) in Yemen, Rep. in 1995 to that in 1996?
Make the answer very short. 0.41. What is the ratio of the Exports (in Local Currency Unit) in Chad in 1995 to that in 1997?
Provide a succinct answer. 0.95. What is the ratio of the Exports (in Local Currency Unit) in Costa Rica in 1995 to that in 1997?
Your answer should be compact. 0.65. What is the ratio of the Exports (in Local Currency Unit) in Guyana in 1995 to that in 1997?
Make the answer very short. 0.84. What is the ratio of the Exports (in Local Currency Unit) in Yemen, Rep. in 1995 to that in 1997?
Offer a very short reply. 0.36. What is the ratio of the Exports (in Local Currency Unit) of Chad in 1996 to that in 1997?
Make the answer very short. 0.86. What is the ratio of the Exports (in Local Currency Unit) of Costa Rica in 1996 to that in 1997?
Make the answer very short. 0.8. What is the ratio of the Exports (in Local Currency Unit) in Guyana in 1996 to that in 1997?
Ensure brevity in your answer.  0.96. What is the ratio of the Exports (in Local Currency Unit) in Yemen, Rep. in 1996 to that in 1997?
Your answer should be very brief. 0.89. What is the difference between the highest and the second highest Exports (in Local Currency Unit) of Chad?
Give a very brief answer. 8.92e+09. What is the difference between the highest and the second highest Exports (in Local Currency Unit) in Costa Rica?
Make the answer very short. 2.49e+11. What is the difference between the highest and the second highest Exports (in Local Currency Unit) of Guyana?
Ensure brevity in your answer.  4.68e+09. What is the difference between the highest and the second highest Exports (in Local Currency Unit) in Yemen, Rep.?
Your answer should be compact. 3.52e+1. What is the difference between the highest and the lowest Exports (in Local Currency Unit) of Chad?
Make the answer very short. 1.12e+11. What is the difference between the highest and the lowest Exports (in Local Currency Unit) of Costa Rica?
Make the answer very short. 8.10e+11. What is the difference between the highest and the lowest Exports (in Local Currency Unit) of Guyana?
Keep it short and to the point. 4.75e+1. What is the difference between the highest and the lowest Exports (in Local Currency Unit) of Yemen, Rep.?
Give a very brief answer. 2.98e+11. 